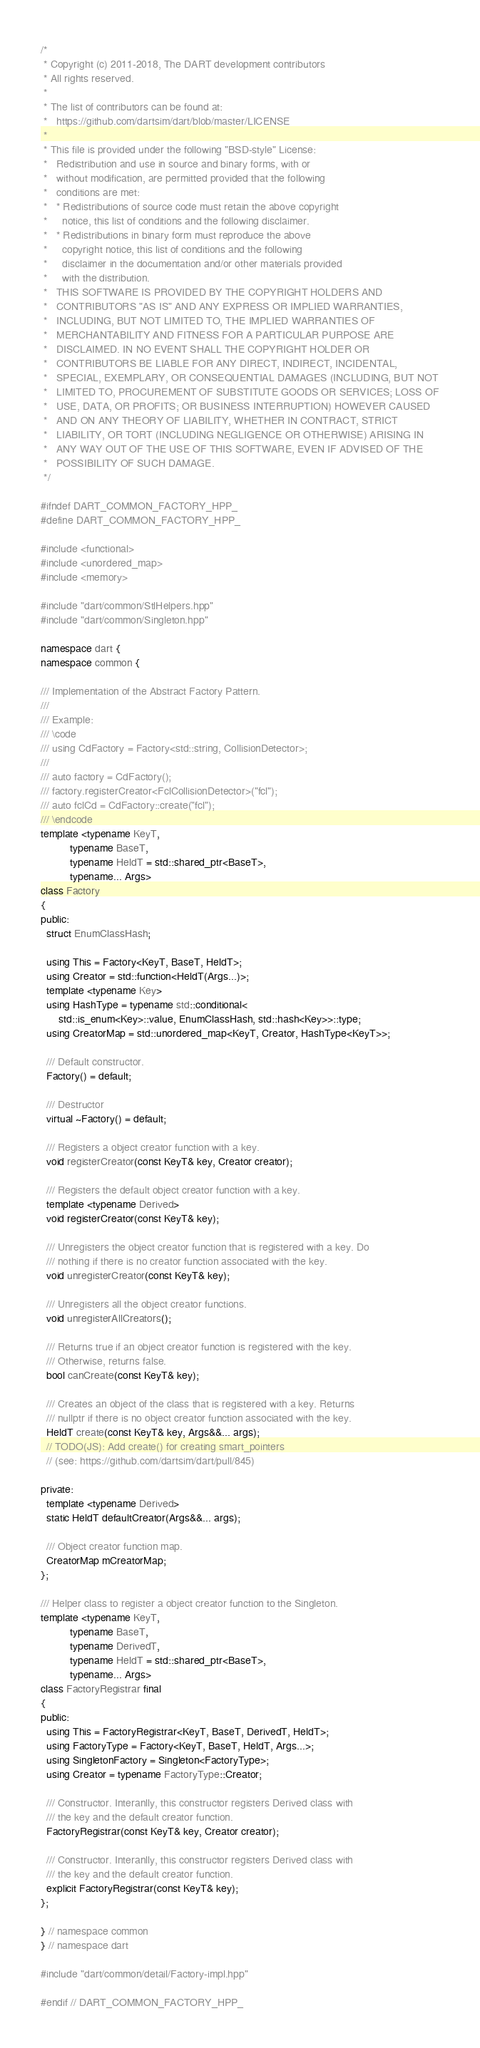<code> <loc_0><loc_0><loc_500><loc_500><_C++_>/*
 * Copyright (c) 2011-2018, The DART development contributors
 * All rights reserved.
 *
 * The list of contributors can be found at:
 *   https://github.com/dartsim/dart/blob/master/LICENSE
 *
 * This file is provided under the following "BSD-style" License:
 *   Redistribution and use in source and binary forms, with or
 *   without modification, are permitted provided that the following
 *   conditions are met:
 *   * Redistributions of source code must retain the above copyright
 *     notice, this list of conditions and the following disclaimer.
 *   * Redistributions in binary form must reproduce the above
 *     copyright notice, this list of conditions and the following
 *     disclaimer in the documentation and/or other materials provided
 *     with the distribution.
 *   THIS SOFTWARE IS PROVIDED BY THE COPYRIGHT HOLDERS AND
 *   CONTRIBUTORS "AS IS" AND ANY EXPRESS OR IMPLIED WARRANTIES,
 *   INCLUDING, BUT NOT LIMITED TO, THE IMPLIED WARRANTIES OF
 *   MERCHANTABILITY AND FITNESS FOR A PARTICULAR PURPOSE ARE
 *   DISCLAIMED. IN NO EVENT SHALL THE COPYRIGHT HOLDER OR
 *   CONTRIBUTORS BE LIABLE FOR ANY DIRECT, INDIRECT, INCIDENTAL,
 *   SPECIAL, EXEMPLARY, OR CONSEQUENTIAL DAMAGES (INCLUDING, BUT NOT
 *   LIMITED TO, PROCUREMENT OF SUBSTITUTE GOODS OR SERVICES; LOSS OF
 *   USE, DATA, OR PROFITS; OR BUSINESS INTERRUPTION) HOWEVER CAUSED
 *   AND ON ANY THEORY OF LIABILITY, WHETHER IN CONTRACT, STRICT
 *   LIABILITY, OR TORT (INCLUDING NEGLIGENCE OR OTHERWISE) ARISING IN
 *   ANY WAY OUT OF THE USE OF THIS SOFTWARE, EVEN IF ADVISED OF THE
 *   POSSIBILITY OF SUCH DAMAGE.
 */

#ifndef DART_COMMON_FACTORY_HPP_
#define DART_COMMON_FACTORY_HPP_

#include <functional>
#include <unordered_map>
#include <memory>

#include "dart/common/StlHelpers.hpp"
#include "dart/common/Singleton.hpp"

namespace dart {
namespace common {

/// Implementation of the Abstract Factory Pattern.
///
/// Example:
/// \code
/// using CdFactory = Factory<std::string, CollisionDetector>;
///
/// auto factory = CdFactory();
/// factory.registerCreator<FclCollisionDetector>("fcl");
/// auto fclCd = CdFactory::create("fcl");
/// \endcode
template <typename KeyT,
          typename BaseT,
          typename HeldT = std::shared_ptr<BaseT>,
          typename... Args>
class Factory
{
public:
  struct EnumClassHash;

  using This = Factory<KeyT, BaseT, HeldT>;
  using Creator = std::function<HeldT(Args...)>;
  template <typename Key>
  using HashType = typename std::conditional<
      std::is_enum<Key>::value, EnumClassHash, std::hash<Key>>::type;
  using CreatorMap = std::unordered_map<KeyT, Creator, HashType<KeyT>>;

  /// Default constructor.
  Factory() = default;

  /// Destructor
  virtual ~Factory() = default;

  /// Registers a object creator function with a key.
  void registerCreator(const KeyT& key, Creator creator);

  /// Registers the default object creator function with a key.
  template <typename Derived>
  void registerCreator(const KeyT& key);

  /// Unregisters the object creator function that is registered with a key. Do
  /// nothing if there is no creator function associated with the key.
  void unregisterCreator(const KeyT& key);

  /// Unregisters all the object creator functions.
  void unregisterAllCreators();

  /// Returns true if an object creator function is registered with the key.
  /// Otherwise, returns false.
  bool canCreate(const KeyT& key);

  /// Creates an object of the class that is registered with a key. Returns
  /// nullptr if there is no object creator function associated with the key.
  HeldT create(const KeyT& key, Args&&... args);
  // TODO(JS): Add create() for creating smart_pointers
  // (see: https://github.com/dartsim/dart/pull/845)

private:
  template <typename Derived>
  static HeldT defaultCreator(Args&&... args);

  /// Object creator function map.
  CreatorMap mCreatorMap;
};

/// Helper class to register a object creator function to the Singleton.
template <typename KeyT,
          typename BaseT,
          typename DerivedT,
          typename HeldT = std::shared_ptr<BaseT>,
          typename... Args>
class FactoryRegistrar final
{
public:
  using This = FactoryRegistrar<KeyT, BaseT, DerivedT, HeldT>;
  using FactoryType = Factory<KeyT, BaseT, HeldT, Args...>;
  using SingletonFactory = Singleton<FactoryType>;
  using Creator = typename FactoryType::Creator;

  /// Constructor. Interanlly, this constructor registers Derived class with
  /// the key and the default creator function.
  FactoryRegistrar(const KeyT& key, Creator creator);

  /// Constructor. Interanlly, this constructor registers Derived class with
  /// the key and the default creator function.
  explicit FactoryRegistrar(const KeyT& key);
};

} // namespace common
} // namespace dart

#include "dart/common/detail/Factory-impl.hpp"

#endif // DART_COMMON_FACTORY_HPP_
</code> 